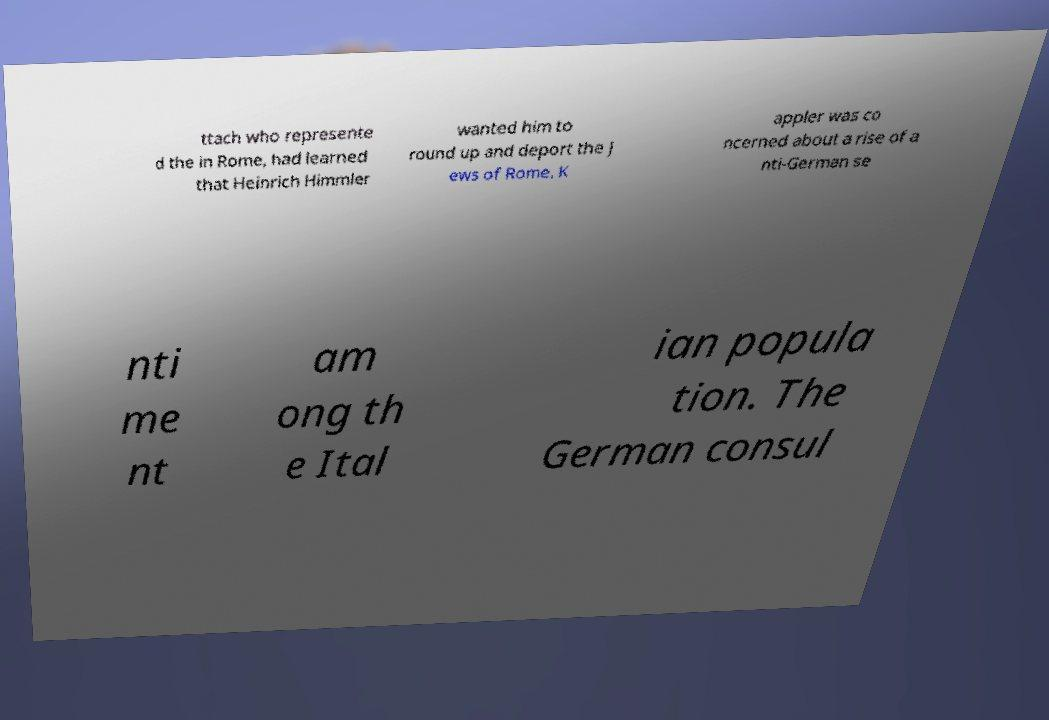Can you accurately transcribe the text from the provided image for me? ttach who represente d the in Rome, had learned that Heinrich Himmler wanted him to round up and deport the J ews of Rome. K appler was co ncerned about a rise of a nti-German se nti me nt am ong th e Ital ian popula tion. The German consul 